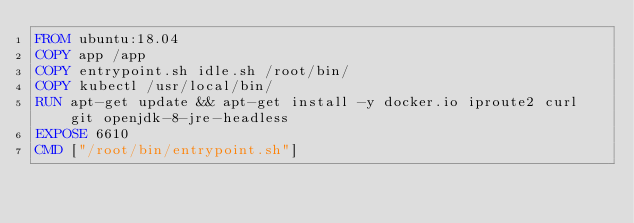<code> <loc_0><loc_0><loc_500><loc_500><_Dockerfile_>FROM ubuntu:18.04
COPY app /app
COPY entrypoint.sh idle.sh /root/bin/
COPY kubectl /usr/local/bin/
RUN apt-get update && apt-get install -y docker.io iproute2 curl git openjdk-8-jre-headless 
EXPOSE 6610
CMD ["/root/bin/entrypoint.sh"]
</code> 